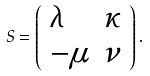Convert formula to latex. <formula><loc_0><loc_0><loc_500><loc_500>S = \left ( \begin{array} { l l } { \lambda } & { \kappa } \\ { - \mu } & { \nu } \end{array} \right ) .</formula> 